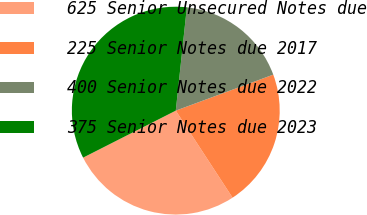Convert chart. <chart><loc_0><loc_0><loc_500><loc_500><pie_chart><fcel>625 Senior Unsecured Notes due<fcel>225 Senior Notes due 2017<fcel>400 Senior Notes due 2022<fcel>375 Senior Notes due 2023<nl><fcel>26.73%<fcel>21.43%<fcel>17.67%<fcel>34.17%<nl></chart> 